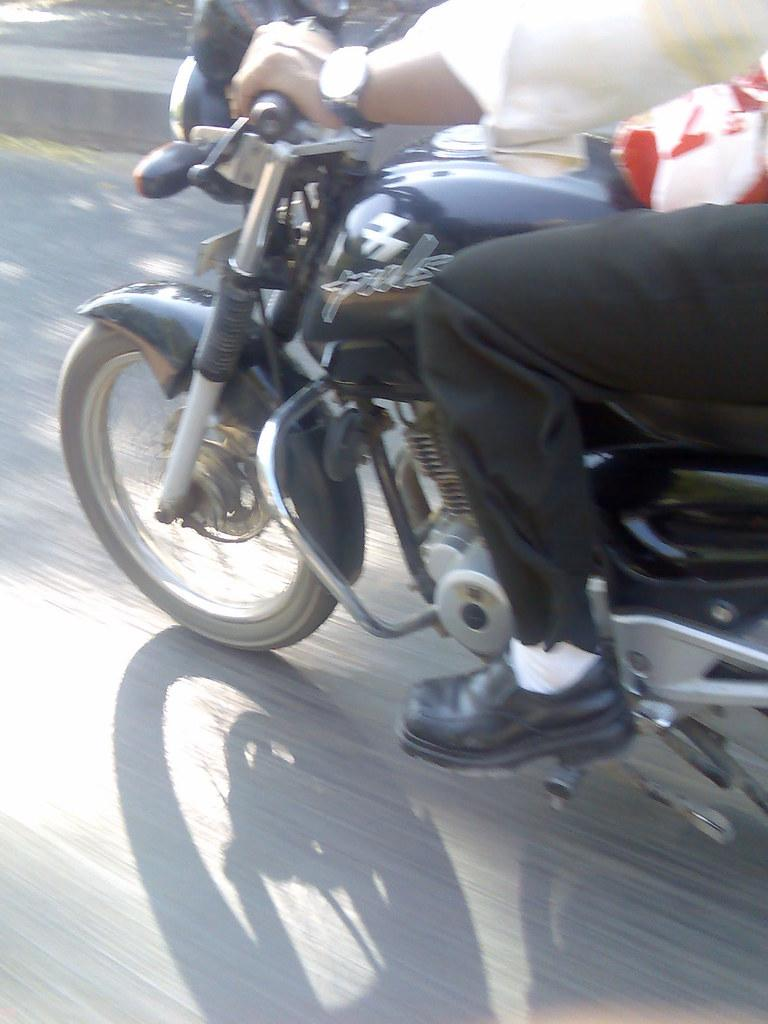What is the main subject of the image? There is a person in the image. What is the person doing in the image? The person is sitting on a bike. Where is the bike located in the image? The bike is on the road. What type of roof can be seen on the bike in the image? There is no roof present on the bike in the image. How does the person's fear of society affect their actions in the image? The image does not provide any information about the person's fear of society, so we cannot determine how it affects their actions. 